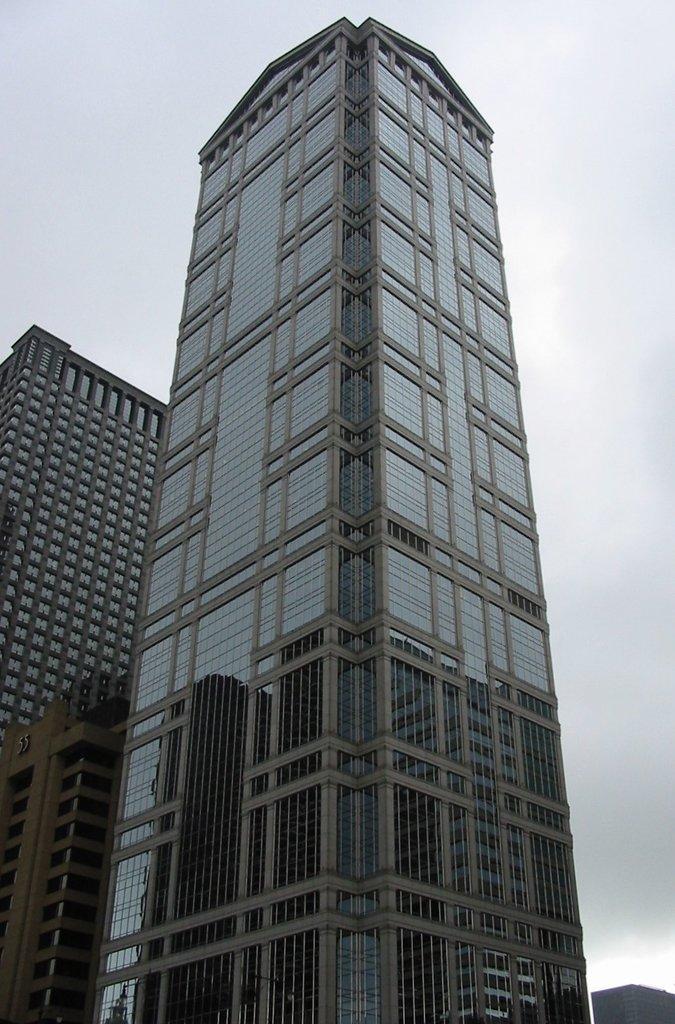How would you summarize this image in a sentence or two? In this picture we can see some buildings. 